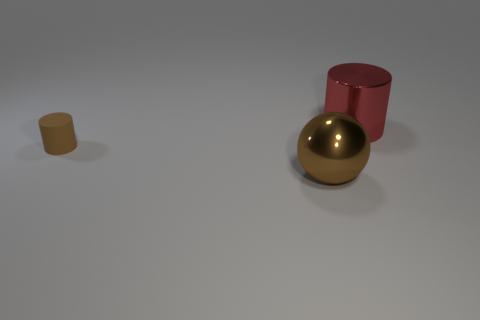Is there any other thing that is the same size as the matte object?
Ensure brevity in your answer.  No. There is a shiny thing that is behind the cylinder that is in front of the shiny object behind the tiny brown object; what size is it?
Offer a terse response. Large. There is a metallic thing in front of the red metal thing; is its color the same as the small matte cylinder?
Your answer should be compact. Yes. What is the material of the big sphere that is the same color as the tiny thing?
Make the answer very short. Metal. The metal thing that is the same color as the tiny cylinder is what size?
Offer a very short reply. Large. Is there a object that has the same color as the metal ball?
Offer a very short reply. Yes. How many other objects are there of the same shape as the tiny object?
Keep it short and to the point. 1. What shape is the large metal thing behind the small matte object?
Provide a succinct answer. Cylinder. Do the tiny matte object and the shiny thing that is to the left of the red metal cylinder have the same shape?
Give a very brief answer. No. What is the size of the thing that is behind the big brown object and to the right of the small brown cylinder?
Provide a short and direct response. Large. 